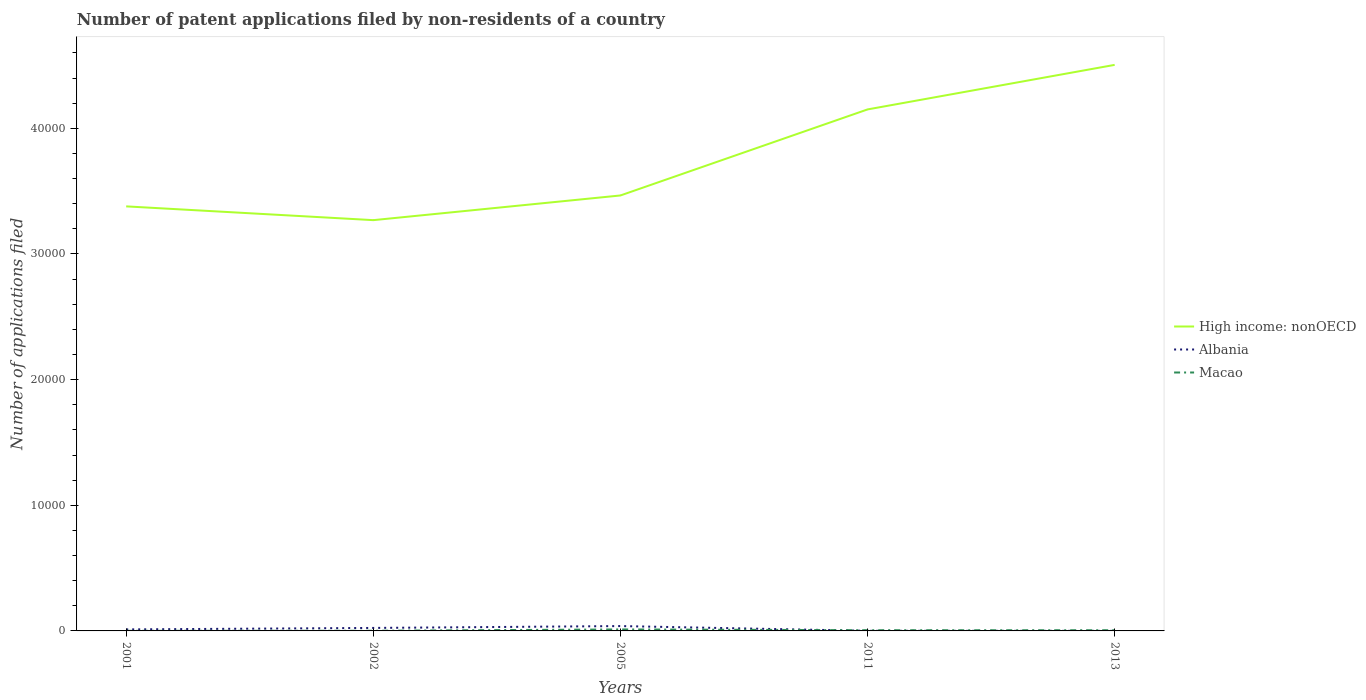How many different coloured lines are there?
Offer a terse response. 3. Is the number of lines equal to the number of legend labels?
Your answer should be very brief. Yes. What is the total number of applications filed in Albania in the graph?
Make the answer very short. 116. What is the difference between the highest and the second highest number of applications filed in Albania?
Provide a succinct answer. 382. Is the number of applications filed in Albania strictly greater than the number of applications filed in High income: nonOECD over the years?
Your answer should be very brief. Yes. What is the difference between two consecutive major ticks on the Y-axis?
Your answer should be compact. 10000. Does the graph contain grids?
Give a very brief answer. No. Where does the legend appear in the graph?
Provide a short and direct response. Center right. What is the title of the graph?
Give a very brief answer. Number of patent applications filed by non-residents of a country. What is the label or title of the Y-axis?
Provide a succinct answer. Number of applications filed. What is the Number of applications filed in High income: nonOECD in 2001?
Your answer should be very brief. 3.38e+04. What is the Number of applications filed of Albania in 2001?
Offer a very short reply. 120. What is the Number of applications filed of Macao in 2001?
Your response must be concise. 7. What is the Number of applications filed of High income: nonOECD in 2002?
Make the answer very short. 3.27e+04. What is the Number of applications filed in Albania in 2002?
Make the answer very short. 238. What is the Number of applications filed of Macao in 2002?
Your response must be concise. 12. What is the Number of applications filed in High income: nonOECD in 2005?
Offer a terse response. 3.47e+04. What is the Number of applications filed of Albania in 2005?
Keep it short and to the point. 386. What is the Number of applications filed of Macao in 2005?
Provide a short and direct response. 119. What is the Number of applications filed in High income: nonOECD in 2011?
Give a very brief answer. 4.15e+04. What is the Number of applications filed in High income: nonOECD in 2013?
Make the answer very short. 4.51e+04. What is the Number of applications filed of Albania in 2013?
Offer a very short reply. 4. What is the Number of applications filed of Macao in 2013?
Your response must be concise. 54. Across all years, what is the maximum Number of applications filed of High income: nonOECD?
Provide a succinct answer. 4.51e+04. Across all years, what is the maximum Number of applications filed in Albania?
Ensure brevity in your answer.  386. Across all years, what is the maximum Number of applications filed in Macao?
Your answer should be very brief. 119. Across all years, what is the minimum Number of applications filed in High income: nonOECD?
Your response must be concise. 3.27e+04. Across all years, what is the minimum Number of applications filed in Albania?
Provide a succinct answer. 4. What is the total Number of applications filed in High income: nonOECD in the graph?
Provide a short and direct response. 1.88e+05. What is the total Number of applications filed of Albania in the graph?
Your answer should be very brief. 756. What is the total Number of applications filed of Macao in the graph?
Your response must be concise. 248. What is the difference between the Number of applications filed of High income: nonOECD in 2001 and that in 2002?
Offer a very short reply. 1096. What is the difference between the Number of applications filed in Albania in 2001 and that in 2002?
Your answer should be compact. -118. What is the difference between the Number of applications filed of High income: nonOECD in 2001 and that in 2005?
Offer a very short reply. -868. What is the difference between the Number of applications filed of Albania in 2001 and that in 2005?
Ensure brevity in your answer.  -266. What is the difference between the Number of applications filed of Macao in 2001 and that in 2005?
Offer a very short reply. -112. What is the difference between the Number of applications filed in High income: nonOECD in 2001 and that in 2011?
Make the answer very short. -7716. What is the difference between the Number of applications filed of Albania in 2001 and that in 2011?
Keep it short and to the point. 112. What is the difference between the Number of applications filed of Macao in 2001 and that in 2011?
Your answer should be very brief. -49. What is the difference between the Number of applications filed of High income: nonOECD in 2001 and that in 2013?
Offer a terse response. -1.13e+04. What is the difference between the Number of applications filed of Albania in 2001 and that in 2013?
Make the answer very short. 116. What is the difference between the Number of applications filed in Macao in 2001 and that in 2013?
Keep it short and to the point. -47. What is the difference between the Number of applications filed in High income: nonOECD in 2002 and that in 2005?
Provide a short and direct response. -1964. What is the difference between the Number of applications filed in Albania in 2002 and that in 2005?
Offer a terse response. -148. What is the difference between the Number of applications filed in Macao in 2002 and that in 2005?
Give a very brief answer. -107. What is the difference between the Number of applications filed in High income: nonOECD in 2002 and that in 2011?
Your answer should be compact. -8812. What is the difference between the Number of applications filed in Albania in 2002 and that in 2011?
Your answer should be compact. 230. What is the difference between the Number of applications filed of Macao in 2002 and that in 2011?
Make the answer very short. -44. What is the difference between the Number of applications filed in High income: nonOECD in 2002 and that in 2013?
Your response must be concise. -1.24e+04. What is the difference between the Number of applications filed of Albania in 2002 and that in 2013?
Provide a succinct answer. 234. What is the difference between the Number of applications filed in Macao in 2002 and that in 2013?
Give a very brief answer. -42. What is the difference between the Number of applications filed in High income: nonOECD in 2005 and that in 2011?
Your answer should be very brief. -6848. What is the difference between the Number of applications filed of Albania in 2005 and that in 2011?
Provide a succinct answer. 378. What is the difference between the Number of applications filed in Macao in 2005 and that in 2011?
Keep it short and to the point. 63. What is the difference between the Number of applications filed in High income: nonOECD in 2005 and that in 2013?
Ensure brevity in your answer.  -1.04e+04. What is the difference between the Number of applications filed in Albania in 2005 and that in 2013?
Your answer should be very brief. 382. What is the difference between the Number of applications filed of Macao in 2005 and that in 2013?
Give a very brief answer. 65. What is the difference between the Number of applications filed of High income: nonOECD in 2011 and that in 2013?
Make the answer very short. -3546. What is the difference between the Number of applications filed of Albania in 2011 and that in 2013?
Provide a succinct answer. 4. What is the difference between the Number of applications filed of High income: nonOECD in 2001 and the Number of applications filed of Albania in 2002?
Give a very brief answer. 3.36e+04. What is the difference between the Number of applications filed of High income: nonOECD in 2001 and the Number of applications filed of Macao in 2002?
Ensure brevity in your answer.  3.38e+04. What is the difference between the Number of applications filed in Albania in 2001 and the Number of applications filed in Macao in 2002?
Your answer should be compact. 108. What is the difference between the Number of applications filed of High income: nonOECD in 2001 and the Number of applications filed of Albania in 2005?
Your response must be concise. 3.34e+04. What is the difference between the Number of applications filed of High income: nonOECD in 2001 and the Number of applications filed of Macao in 2005?
Provide a succinct answer. 3.37e+04. What is the difference between the Number of applications filed in High income: nonOECD in 2001 and the Number of applications filed in Albania in 2011?
Offer a very short reply. 3.38e+04. What is the difference between the Number of applications filed in High income: nonOECD in 2001 and the Number of applications filed in Macao in 2011?
Ensure brevity in your answer.  3.37e+04. What is the difference between the Number of applications filed of High income: nonOECD in 2001 and the Number of applications filed of Albania in 2013?
Offer a very short reply. 3.38e+04. What is the difference between the Number of applications filed of High income: nonOECD in 2001 and the Number of applications filed of Macao in 2013?
Ensure brevity in your answer.  3.37e+04. What is the difference between the Number of applications filed of High income: nonOECD in 2002 and the Number of applications filed of Albania in 2005?
Make the answer very short. 3.23e+04. What is the difference between the Number of applications filed in High income: nonOECD in 2002 and the Number of applications filed in Macao in 2005?
Provide a succinct answer. 3.26e+04. What is the difference between the Number of applications filed in Albania in 2002 and the Number of applications filed in Macao in 2005?
Make the answer very short. 119. What is the difference between the Number of applications filed of High income: nonOECD in 2002 and the Number of applications filed of Albania in 2011?
Your answer should be very brief. 3.27e+04. What is the difference between the Number of applications filed in High income: nonOECD in 2002 and the Number of applications filed in Macao in 2011?
Your answer should be very brief. 3.26e+04. What is the difference between the Number of applications filed in Albania in 2002 and the Number of applications filed in Macao in 2011?
Provide a succinct answer. 182. What is the difference between the Number of applications filed of High income: nonOECD in 2002 and the Number of applications filed of Albania in 2013?
Your answer should be very brief. 3.27e+04. What is the difference between the Number of applications filed of High income: nonOECD in 2002 and the Number of applications filed of Macao in 2013?
Your response must be concise. 3.26e+04. What is the difference between the Number of applications filed in Albania in 2002 and the Number of applications filed in Macao in 2013?
Provide a succinct answer. 184. What is the difference between the Number of applications filed of High income: nonOECD in 2005 and the Number of applications filed of Albania in 2011?
Offer a very short reply. 3.46e+04. What is the difference between the Number of applications filed of High income: nonOECD in 2005 and the Number of applications filed of Macao in 2011?
Make the answer very short. 3.46e+04. What is the difference between the Number of applications filed of Albania in 2005 and the Number of applications filed of Macao in 2011?
Offer a terse response. 330. What is the difference between the Number of applications filed of High income: nonOECD in 2005 and the Number of applications filed of Albania in 2013?
Provide a succinct answer. 3.47e+04. What is the difference between the Number of applications filed in High income: nonOECD in 2005 and the Number of applications filed in Macao in 2013?
Provide a short and direct response. 3.46e+04. What is the difference between the Number of applications filed of Albania in 2005 and the Number of applications filed of Macao in 2013?
Provide a succinct answer. 332. What is the difference between the Number of applications filed in High income: nonOECD in 2011 and the Number of applications filed in Albania in 2013?
Ensure brevity in your answer.  4.15e+04. What is the difference between the Number of applications filed of High income: nonOECD in 2011 and the Number of applications filed of Macao in 2013?
Ensure brevity in your answer.  4.15e+04. What is the difference between the Number of applications filed in Albania in 2011 and the Number of applications filed in Macao in 2013?
Offer a very short reply. -46. What is the average Number of applications filed of High income: nonOECD per year?
Your response must be concise. 3.75e+04. What is the average Number of applications filed of Albania per year?
Your answer should be very brief. 151.2. What is the average Number of applications filed of Macao per year?
Make the answer very short. 49.6. In the year 2001, what is the difference between the Number of applications filed in High income: nonOECD and Number of applications filed in Albania?
Make the answer very short. 3.37e+04. In the year 2001, what is the difference between the Number of applications filed of High income: nonOECD and Number of applications filed of Macao?
Keep it short and to the point. 3.38e+04. In the year 2001, what is the difference between the Number of applications filed of Albania and Number of applications filed of Macao?
Provide a short and direct response. 113. In the year 2002, what is the difference between the Number of applications filed of High income: nonOECD and Number of applications filed of Albania?
Provide a succinct answer. 3.25e+04. In the year 2002, what is the difference between the Number of applications filed in High income: nonOECD and Number of applications filed in Macao?
Offer a terse response. 3.27e+04. In the year 2002, what is the difference between the Number of applications filed in Albania and Number of applications filed in Macao?
Make the answer very short. 226. In the year 2005, what is the difference between the Number of applications filed of High income: nonOECD and Number of applications filed of Albania?
Make the answer very short. 3.43e+04. In the year 2005, what is the difference between the Number of applications filed in High income: nonOECD and Number of applications filed in Macao?
Keep it short and to the point. 3.45e+04. In the year 2005, what is the difference between the Number of applications filed of Albania and Number of applications filed of Macao?
Ensure brevity in your answer.  267. In the year 2011, what is the difference between the Number of applications filed of High income: nonOECD and Number of applications filed of Albania?
Give a very brief answer. 4.15e+04. In the year 2011, what is the difference between the Number of applications filed in High income: nonOECD and Number of applications filed in Macao?
Give a very brief answer. 4.14e+04. In the year 2011, what is the difference between the Number of applications filed in Albania and Number of applications filed in Macao?
Give a very brief answer. -48. In the year 2013, what is the difference between the Number of applications filed in High income: nonOECD and Number of applications filed in Albania?
Offer a terse response. 4.50e+04. In the year 2013, what is the difference between the Number of applications filed in High income: nonOECD and Number of applications filed in Macao?
Make the answer very short. 4.50e+04. In the year 2013, what is the difference between the Number of applications filed of Albania and Number of applications filed of Macao?
Provide a succinct answer. -50. What is the ratio of the Number of applications filed in High income: nonOECD in 2001 to that in 2002?
Your answer should be compact. 1.03. What is the ratio of the Number of applications filed in Albania in 2001 to that in 2002?
Your response must be concise. 0.5. What is the ratio of the Number of applications filed in Macao in 2001 to that in 2002?
Provide a short and direct response. 0.58. What is the ratio of the Number of applications filed of High income: nonOECD in 2001 to that in 2005?
Provide a short and direct response. 0.97. What is the ratio of the Number of applications filed of Albania in 2001 to that in 2005?
Your answer should be very brief. 0.31. What is the ratio of the Number of applications filed in Macao in 2001 to that in 2005?
Offer a terse response. 0.06. What is the ratio of the Number of applications filed in High income: nonOECD in 2001 to that in 2011?
Your answer should be very brief. 0.81. What is the ratio of the Number of applications filed of Macao in 2001 to that in 2011?
Make the answer very short. 0.12. What is the ratio of the Number of applications filed of Macao in 2001 to that in 2013?
Provide a succinct answer. 0.13. What is the ratio of the Number of applications filed of High income: nonOECD in 2002 to that in 2005?
Provide a succinct answer. 0.94. What is the ratio of the Number of applications filed in Albania in 2002 to that in 2005?
Your response must be concise. 0.62. What is the ratio of the Number of applications filed in Macao in 2002 to that in 2005?
Give a very brief answer. 0.1. What is the ratio of the Number of applications filed in High income: nonOECD in 2002 to that in 2011?
Your response must be concise. 0.79. What is the ratio of the Number of applications filed in Albania in 2002 to that in 2011?
Provide a short and direct response. 29.75. What is the ratio of the Number of applications filed in Macao in 2002 to that in 2011?
Keep it short and to the point. 0.21. What is the ratio of the Number of applications filed of High income: nonOECD in 2002 to that in 2013?
Provide a short and direct response. 0.73. What is the ratio of the Number of applications filed of Albania in 2002 to that in 2013?
Provide a short and direct response. 59.5. What is the ratio of the Number of applications filed of Macao in 2002 to that in 2013?
Provide a short and direct response. 0.22. What is the ratio of the Number of applications filed in High income: nonOECD in 2005 to that in 2011?
Your answer should be compact. 0.83. What is the ratio of the Number of applications filed of Albania in 2005 to that in 2011?
Make the answer very short. 48.25. What is the ratio of the Number of applications filed in Macao in 2005 to that in 2011?
Give a very brief answer. 2.12. What is the ratio of the Number of applications filed in High income: nonOECD in 2005 to that in 2013?
Keep it short and to the point. 0.77. What is the ratio of the Number of applications filed in Albania in 2005 to that in 2013?
Your answer should be very brief. 96.5. What is the ratio of the Number of applications filed of Macao in 2005 to that in 2013?
Provide a short and direct response. 2.2. What is the ratio of the Number of applications filed of High income: nonOECD in 2011 to that in 2013?
Keep it short and to the point. 0.92. What is the difference between the highest and the second highest Number of applications filed in High income: nonOECD?
Ensure brevity in your answer.  3546. What is the difference between the highest and the second highest Number of applications filed in Albania?
Keep it short and to the point. 148. What is the difference between the highest and the second highest Number of applications filed in Macao?
Ensure brevity in your answer.  63. What is the difference between the highest and the lowest Number of applications filed of High income: nonOECD?
Ensure brevity in your answer.  1.24e+04. What is the difference between the highest and the lowest Number of applications filed of Albania?
Your answer should be very brief. 382. What is the difference between the highest and the lowest Number of applications filed in Macao?
Keep it short and to the point. 112. 